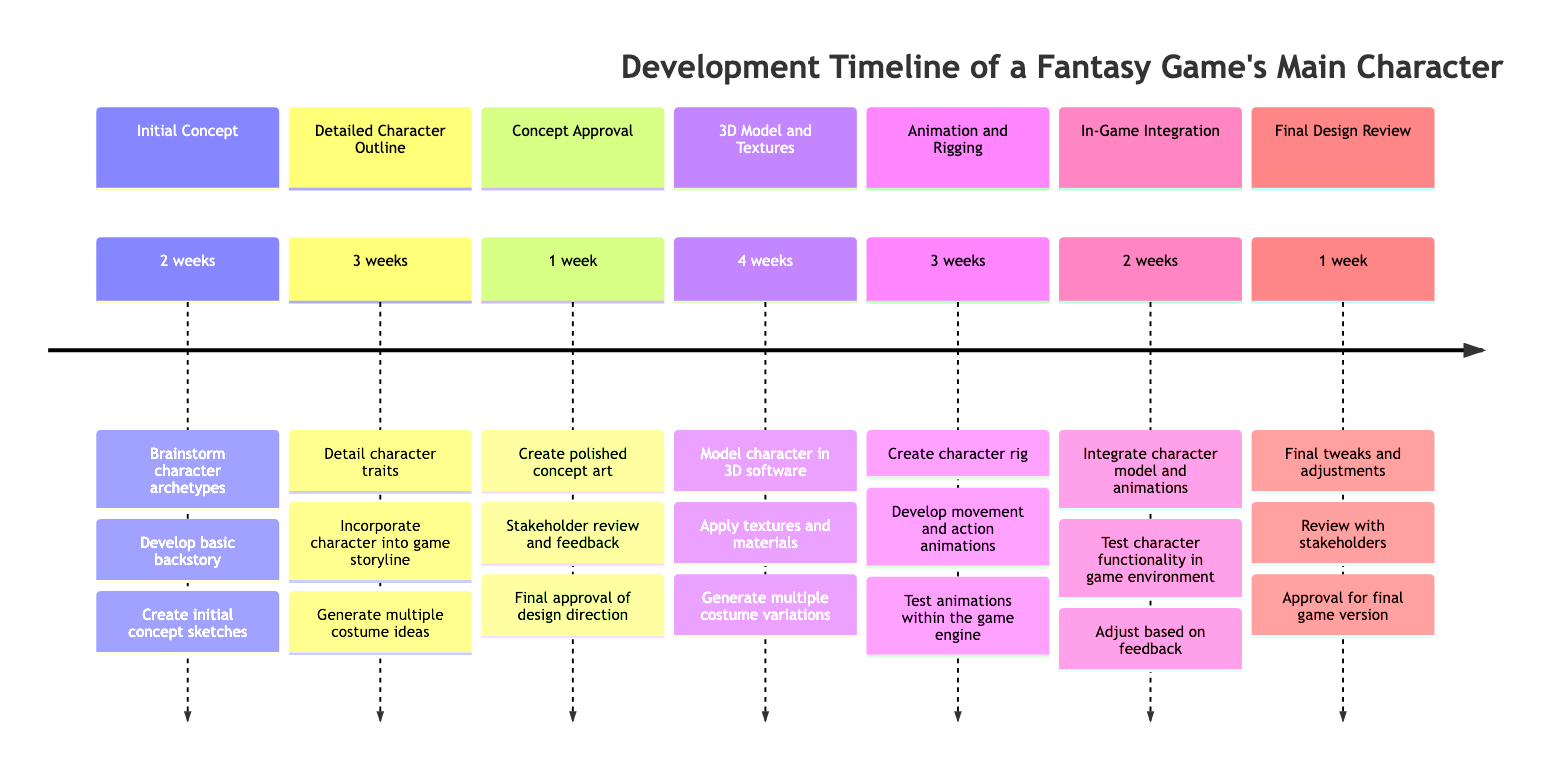What is the duration of the Initial Concept stage? The diagram clearly states that the duration for the Initial Concept stage is listed as "2 weeks."
Answer: 2 weeks Who is involved in the Detailed Character Outline stage? According to the diagram, the team responsible for the Detailed Character Outline includes the Game Writer, Character Designer, and Storyboard Artist.
Answer: Game Writer, Character Designer, Storyboard Artist What is the first task in the Animation and Rigging stage? Upon reviewing the diagram, it's evident that the first task listed for the Animation and Rigging stage is to "Create character rig."
Answer: Create character rig How long does the 3D Model and Textures stage take? The timeline indicates that the 3D Model and Textures stage has a duration of "4 weeks."
Answer: 4 weeks Which stage comes immediately after Concept Approval? By examining the order of stages in the diagram, it's clear that the stage that comes immediately after Concept Approval is the 3D Model and Textures stage.
Answer: 3D Model and Textures What tasks does the In-Game Integration stage include? The diagram specifies that the tasks for the In-Game Integration stage are "Integrate character model and animations," "Test character functionality in game environment," and "Adjust based on feedback."
Answer: Integrate character model and animations, Test character functionality in game environment, Adjust based on feedback How many weeks is allocated for the Final Design Review? The timeline shows that the duration allocated for the Final Design Review stage is "1 week."
Answer: 1 week What is the relationship between the Detailed Character Outline and Concept Approval? The timeline illustrates that the Detailed Character Outline stage precedes the Concept Approval stage, indicating a sequential relationship where the outline must be completed before approval is sought.
Answer: Sequential relationship Which two teams are involved in the final review process? The diagram lists the Creative Director, QA Tester, and Stakeholders as participants in the Final Design Review stage. Therefore, two of these teams can be chosen, such as the Creative Director and Stakeholders.
Answer: Creative Director, Stakeholders 